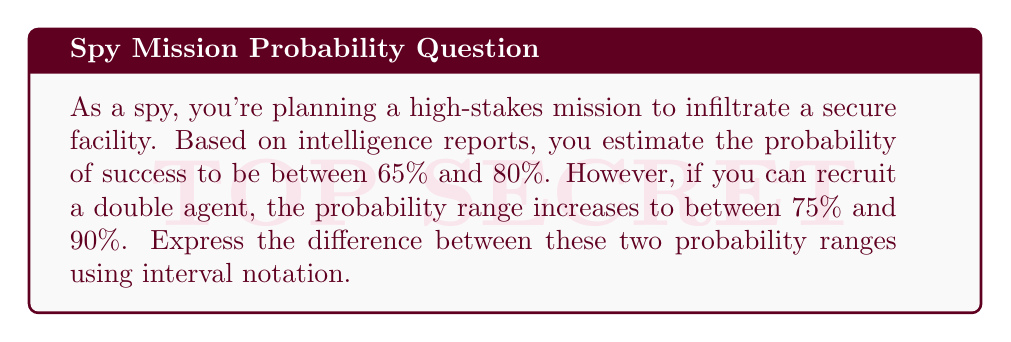Teach me how to tackle this problem. Let's approach this step-by-step:

1) First, let's express the original probability range in interval notation:
   $[0.65, 0.80]$

2) Now, let's express the probability range with the double agent:
   $[0.75, 0.90]$

3) To find the difference between these ranges, we need to subtract the first interval from the second. In interval arithmetic, this is done by subtracting the lower bound of the first interval from the upper bound of the second interval, and the upper bound of the first interval from the lower bound of the second interval:

   $[0.75 - 0.80, 0.90 - 0.65]$

4) Let's calculate:
   $[-0.05, 0.25]$

5) However, probability can't be negative, so we need to adjust the lower bound to 0:
   $[0, 0.25]$

This final interval represents the possible increase in probability of success when recruiting the double agent.
Answer: $[0, 0.25]$ 